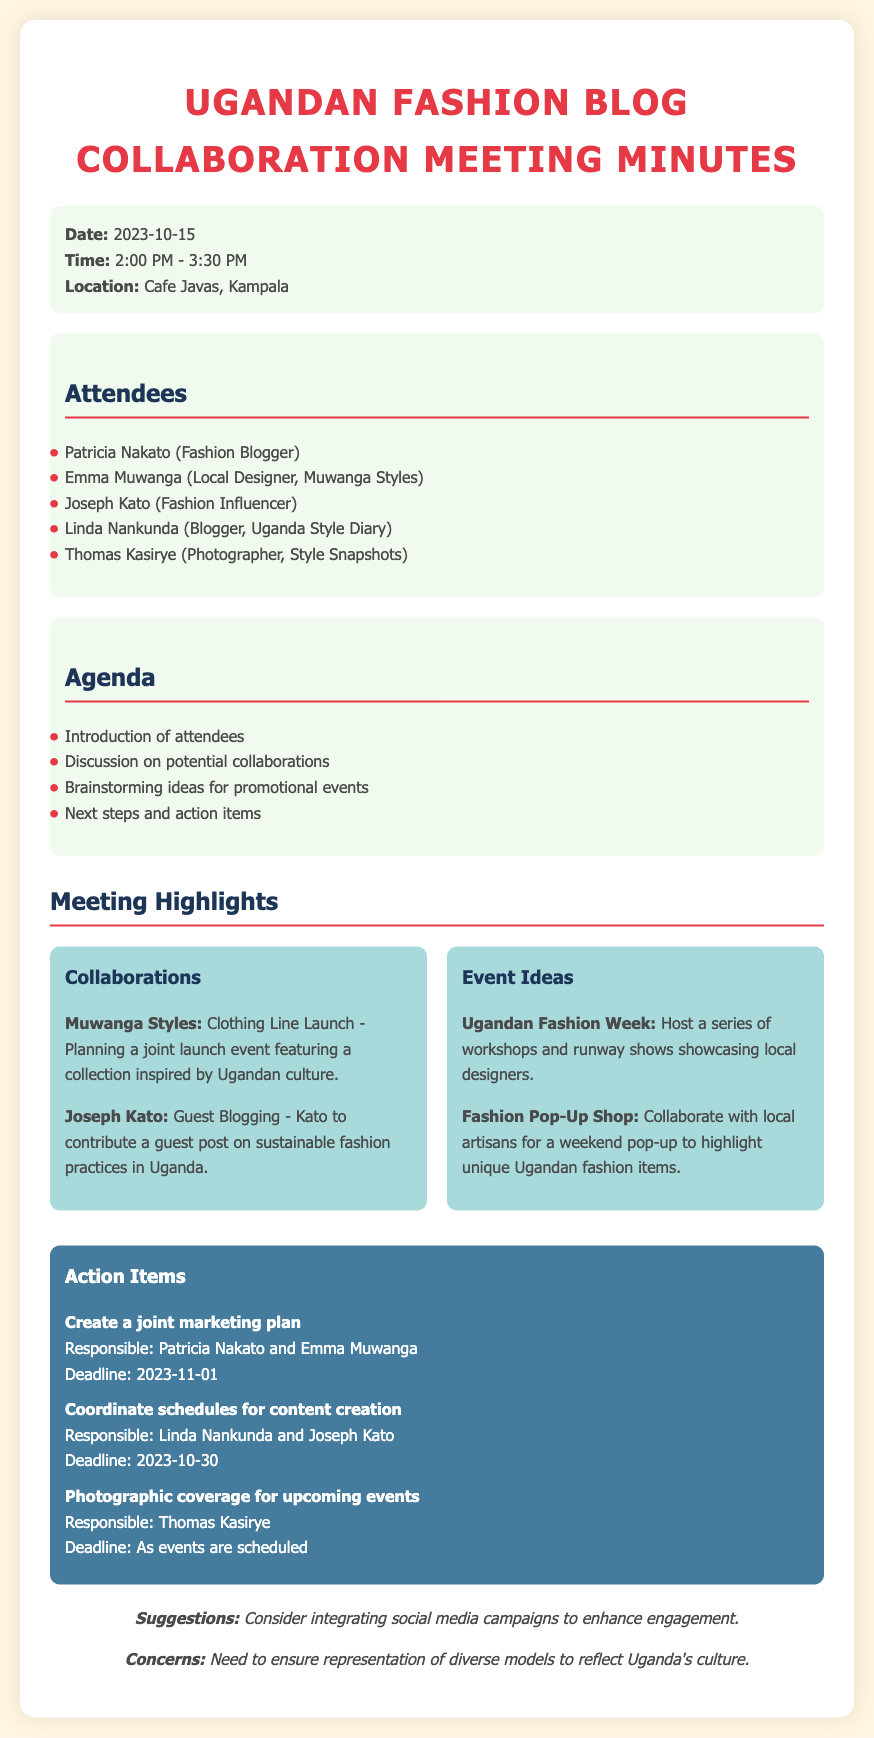What was the date of the meeting? The date of the meeting is specified in the document, listed under meeting details.
Answer: 2023-10-15 Who is responsible for creating a joint marketing plan? The document lists Patricia Nakato and Emma Muwanga as responsible individuals for this action item.
Answer: Patricia Nakato and Emma Muwanga What type of event is associated with Muwanga Styles? The document mentions a clothing line launch event planned with Muwanga Styles.
Answer: Clothing Line Launch How many attendees were present at the meeting? The attendees section lists five individuals participating in the meeting.
Answer: Five What deadline is set for coordinating schedules for content creation? The deadline for this action item is specified in the action items section.
Answer: 2023-10-30 What is one suggestion mentioned in the feedback section? The feedback section provides suggestions regarding engagement enhancement, focusing on social media campaigns.
Answer: Social media campaigns What is the focus of the guest post by Joseph Kato? The document notes that Joseph Kato's guest post will cover sustainable fashion practices in Uganda.
Answer: Sustainable fashion practices What is the location of the meeting? The location is mentioned in the meeting details at the start of the document.
Answer: Cafe Javas, Kampala What is one of the event ideas discussed in the meeting? The highlights section includes hosting a series of workshops and runway shows.
Answer: Ugandan Fashion Week 